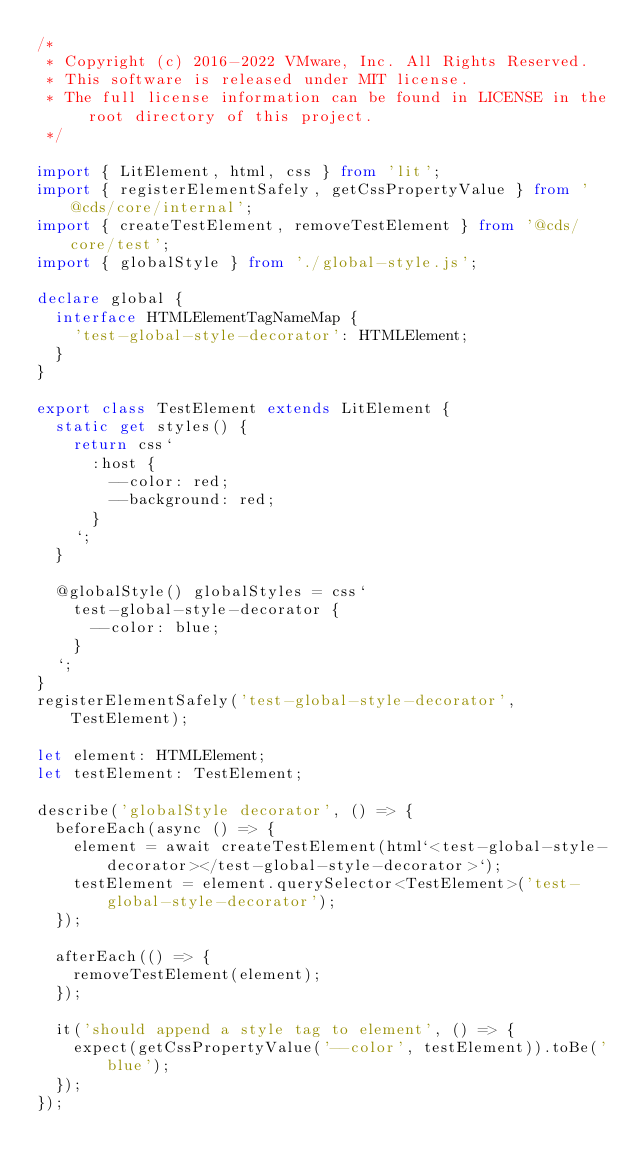Convert code to text. <code><loc_0><loc_0><loc_500><loc_500><_TypeScript_>/*
 * Copyright (c) 2016-2022 VMware, Inc. All Rights Reserved.
 * This software is released under MIT license.
 * The full license information can be found in LICENSE in the root directory of this project.
 */

import { LitElement, html, css } from 'lit';
import { registerElementSafely, getCssPropertyValue } from '@cds/core/internal';
import { createTestElement, removeTestElement } from '@cds/core/test';
import { globalStyle } from './global-style.js';

declare global {
  interface HTMLElementTagNameMap {
    'test-global-style-decorator': HTMLElement;
  }
}

export class TestElement extends LitElement {
  static get styles() {
    return css`
      :host {
        --color: red;
        --background: red;
      }
    `;
  }

  @globalStyle() globalStyles = css`
    test-global-style-decorator {
      --color: blue;
    }
  `;
}
registerElementSafely('test-global-style-decorator', TestElement);

let element: HTMLElement;
let testElement: TestElement;

describe('globalStyle decorator', () => {
  beforeEach(async () => {
    element = await createTestElement(html`<test-global-style-decorator></test-global-style-decorator>`);
    testElement = element.querySelector<TestElement>('test-global-style-decorator');
  });

  afterEach(() => {
    removeTestElement(element);
  });

  it('should append a style tag to element', () => {
    expect(getCssPropertyValue('--color', testElement)).toBe('blue');
  });
});
</code> 